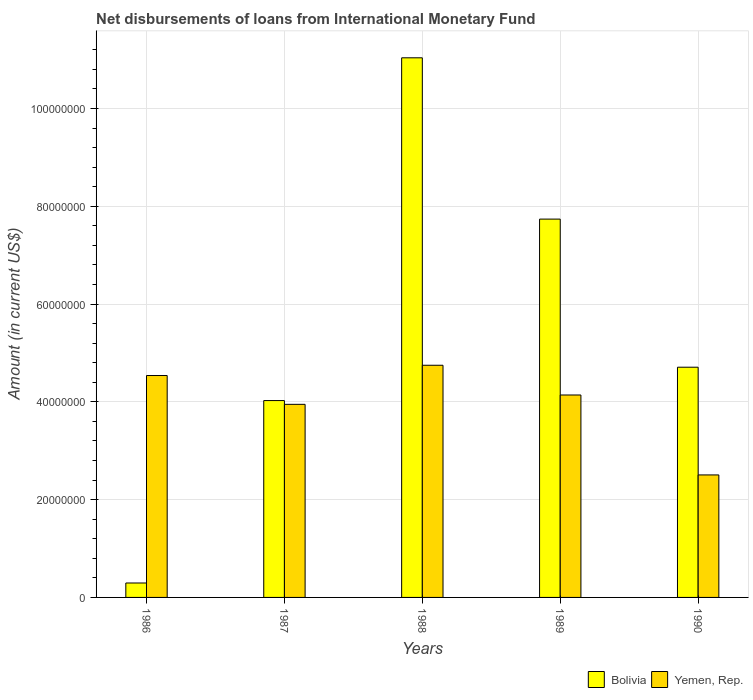How many different coloured bars are there?
Keep it short and to the point. 2. How many groups of bars are there?
Your answer should be very brief. 5. How many bars are there on the 2nd tick from the right?
Make the answer very short. 2. In how many cases, is the number of bars for a given year not equal to the number of legend labels?
Make the answer very short. 0. What is the amount of loans disbursed in Yemen, Rep. in 1988?
Offer a very short reply. 4.75e+07. Across all years, what is the maximum amount of loans disbursed in Yemen, Rep.?
Your answer should be very brief. 4.75e+07. Across all years, what is the minimum amount of loans disbursed in Bolivia?
Offer a very short reply. 2.95e+06. What is the total amount of loans disbursed in Bolivia in the graph?
Ensure brevity in your answer.  2.78e+08. What is the difference between the amount of loans disbursed in Bolivia in 1987 and that in 1988?
Give a very brief answer. -7.01e+07. What is the difference between the amount of loans disbursed in Yemen, Rep. in 1988 and the amount of loans disbursed in Bolivia in 1987?
Your answer should be very brief. 7.22e+06. What is the average amount of loans disbursed in Bolivia per year?
Ensure brevity in your answer.  5.56e+07. In the year 1990, what is the difference between the amount of loans disbursed in Yemen, Rep. and amount of loans disbursed in Bolivia?
Make the answer very short. -2.20e+07. In how many years, is the amount of loans disbursed in Bolivia greater than 16000000 US$?
Make the answer very short. 4. What is the ratio of the amount of loans disbursed in Yemen, Rep. in 1988 to that in 1990?
Keep it short and to the point. 1.9. Is the amount of loans disbursed in Yemen, Rep. in 1987 less than that in 1990?
Ensure brevity in your answer.  No. What is the difference between the highest and the second highest amount of loans disbursed in Bolivia?
Make the answer very short. 3.30e+07. What is the difference between the highest and the lowest amount of loans disbursed in Bolivia?
Your answer should be compact. 1.07e+08. Is the sum of the amount of loans disbursed in Yemen, Rep. in 1989 and 1990 greater than the maximum amount of loans disbursed in Bolivia across all years?
Offer a terse response. No. What does the 2nd bar from the left in 1990 represents?
Provide a short and direct response. Yemen, Rep. What does the 1st bar from the right in 1989 represents?
Keep it short and to the point. Yemen, Rep. How many bars are there?
Your answer should be very brief. 10. Are all the bars in the graph horizontal?
Offer a very short reply. No. How many years are there in the graph?
Offer a very short reply. 5. What is the difference between two consecutive major ticks on the Y-axis?
Your answer should be very brief. 2.00e+07. Are the values on the major ticks of Y-axis written in scientific E-notation?
Provide a short and direct response. No. How many legend labels are there?
Your answer should be compact. 2. What is the title of the graph?
Your answer should be very brief. Net disbursements of loans from International Monetary Fund. Does "Kyrgyz Republic" appear as one of the legend labels in the graph?
Ensure brevity in your answer.  No. What is the label or title of the X-axis?
Offer a very short reply. Years. What is the label or title of the Y-axis?
Make the answer very short. Amount (in current US$). What is the Amount (in current US$) of Bolivia in 1986?
Provide a succinct answer. 2.95e+06. What is the Amount (in current US$) of Yemen, Rep. in 1986?
Make the answer very short. 4.54e+07. What is the Amount (in current US$) of Bolivia in 1987?
Give a very brief answer. 4.03e+07. What is the Amount (in current US$) of Yemen, Rep. in 1987?
Keep it short and to the point. 3.95e+07. What is the Amount (in current US$) of Bolivia in 1988?
Give a very brief answer. 1.10e+08. What is the Amount (in current US$) of Yemen, Rep. in 1988?
Offer a terse response. 4.75e+07. What is the Amount (in current US$) of Bolivia in 1989?
Keep it short and to the point. 7.74e+07. What is the Amount (in current US$) of Yemen, Rep. in 1989?
Offer a terse response. 4.14e+07. What is the Amount (in current US$) of Bolivia in 1990?
Your response must be concise. 4.71e+07. What is the Amount (in current US$) in Yemen, Rep. in 1990?
Ensure brevity in your answer.  2.51e+07. Across all years, what is the maximum Amount (in current US$) in Bolivia?
Your answer should be very brief. 1.10e+08. Across all years, what is the maximum Amount (in current US$) in Yemen, Rep.?
Your response must be concise. 4.75e+07. Across all years, what is the minimum Amount (in current US$) of Bolivia?
Your response must be concise. 2.95e+06. Across all years, what is the minimum Amount (in current US$) of Yemen, Rep.?
Offer a very short reply. 2.51e+07. What is the total Amount (in current US$) of Bolivia in the graph?
Your response must be concise. 2.78e+08. What is the total Amount (in current US$) of Yemen, Rep. in the graph?
Provide a succinct answer. 1.99e+08. What is the difference between the Amount (in current US$) of Bolivia in 1986 and that in 1987?
Your answer should be very brief. -3.73e+07. What is the difference between the Amount (in current US$) in Yemen, Rep. in 1986 and that in 1987?
Your response must be concise. 5.89e+06. What is the difference between the Amount (in current US$) of Bolivia in 1986 and that in 1988?
Make the answer very short. -1.07e+08. What is the difference between the Amount (in current US$) of Yemen, Rep. in 1986 and that in 1988?
Your response must be concise. -2.10e+06. What is the difference between the Amount (in current US$) of Bolivia in 1986 and that in 1989?
Offer a very short reply. -7.44e+07. What is the difference between the Amount (in current US$) in Yemen, Rep. in 1986 and that in 1989?
Your answer should be very brief. 3.98e+06. What is the difference between the Amount (in current US$) in Bolivia in 1986 and that in 1990?
Provide a short and direct response. -4.41e+07. What is the difference between the Amount (in current US$) in Yemen, Rep. in 1986 and that in 1990?
Provide a short and direct response. 2.03e+07. What is the difference between the Amount (in current US$) of Bolivia in 1987 and that in 1988?
Offer a terse response. -7.01e+07. What is the difference between the Amount (in current US$) of Yemen, Rep. in 1987 and that in 1988?
Keep it short and to the point. -7.99e+06. What is the difference between the Amount (in current US$) of Bolivia in 1987 and that in 1989?
Provide a succinct answer. -3.71e+07. What is the difference between the Amount (in current US$) in Yemen, Rep. in 1987 and that in 1989?
Provide a short and direct response. -1.91e+06. What is the difference between the Amount (in current US$) of Bolivia in 1987 and that in 1990?
Your response must be concise. -6.82e+06. What is the difference between the Amount (in current US$) in Yemen, Rep. in 1987 and that in 1990?
Provide a short and direct response. 1.44e+07. What is the difference between the Amount (in current US$) in Bolivia in 1988 and that in 1989?
Your answer should be very brief. 3.30e+07. What is the difference between the Amount (in current US$) of Yemen, Rep. in 1988 and that in 1989?
Offer a terse response. 6.08e+06. What is the difference between the Amount (in current US$) of Bolivia in 1988 and that in 1990?
Make the answer very short. 6.33e+07. What is the difference between the Amount (in current US$) of Yemen, Rep. in 1988 and that in 1990?
Provide a succinct answer. 2.24e+07. What is the difference between the Amount (in current US$) in Bolivia in 1989 and that in 1990?
Provide a succinct answer. 3.03e+07. What is the difference between the Amount (in current US$) of Yemen, Rep. in 1989 and that in 1990?
Your answer should be very brief. 1.64e+07. What is the difference between the Amount (in current US$) in Bolivia in 1986 and the Amount (in current US$) in Yemen, Rep. in 1987?
Give a very brief answer. -3.65e+07. What is the difference between the Amount (in current US$) in Bolivia in 1986 and the Amount (in current US$) in Yemen, Rep. in 1988?
Offer a very short reply. -4.45e+07. What is the difference between the Amount (in current US$) of Bolivia in 1986 and the Amount (in current US$) of Yemen, Rep. in 1989?
Your answer should be very brief. -3.85e+07. What is the difference between the Amount (in current US$) in Bolivia in 1986 and the Amount (in current US$) in Yemen, Rep. in 1990?
Provide a short and direct response. -2.21e+07. What is the difference between the Amount (in current US$) in Bolivia in 1987 and the Amount (in current US$) in Yemen, Rep. in 1988?
Offer a terse response. -7.22e+06. What is the difference between the Amount (in current US$) of Bolivia in 1987 and the Amount (in current US$) of Yemen, Rep. in 1989?
Ensure brevity in your answer.  -1.14e+06. What is the difference between the Amount (in current US$) in Bolivia in 1987 and the Amount (in current US$) in Yemen, Rep. in 1990?
Provide a short and direct response. 1.52e+07. What is the difference between the Amount (in current US$) in Bolivia in 1988 and the Amount (in current US$) in Yemen, Rep. in 1989?
Keep it short and to the point. 6.90e+07. What is the difference between the Amount (in current US$) in Bolivia in 1988 and the Amount (in current US$) in Yemen, Rep. in 1990?
Offer a very short reply. 8.53e+07. What is the difference between the Amount (in current US$) of Bolivia in 1989 and the Amount (in current US$) of Yemen, Rep. in 1990?
Make the answer very short. 5.23e+07. What is the average Amount (in current US$) in Bolivia per year?
Offer a very short reply. 5.56e+07. What is the average Amount (in current US$) in Yemen, Rep. per year?
Keep it short and to the point. 3.98e+07. In the year 1986, what is the difference between the Amount (in current US$) in Bolivia and Amount (in current US$) in Yemen, Rep.?
Ensure brevity in your answer.  -4.24e+07. In the year 1987, what is the difference between the Amount (in current US$) in Bolivia and Amount (in current US$) in Yemen, Rep.?
Your answer should be very brief. 7.70e+05. In the year 1988, what is the difference between the Amount (in current US$) in Bolivia and Amount (in current US$) in Yemen, Rep.?
Provide a short and direct response. 6.29e+07. In the year 1989, what is the difference between the Amount (in current US$) of Bolivia and Amount (in current US$) of Yemen, Rep.?
Offer a terse response. 3.60e+07. In the year 1990, what is the difference between the Amount (in current US$) in Bolivia and Amount (in current US$) in Yemen, Rep.?
Give a very brief answer. 2.20e+07. What is the ratio of the Amount (in current US$) of Bolivia in 1986 to that in 1987?
Provide a succinct answer. 0.07. What is the ratio of the Amount (in current US$) in Yemen, Rep. in 1986 to that in 1987?
Provide a succinct answer. 1.15. What is the ratio of the Amount (in current US$) in Bolivia in 1986 to that in 1988?
Keep it short and to the point. 0.03. What is the ratio of the Amount (in current US$) of Yemen, Rep. in 1986 to that in 1988?
Offer a very short reply. 0.96. What is the ratio of the Amount (in current US$) in Bolivia in 1986 to that in 1989?
Make the answer very short. 0.04. What is the ratio of the Amount (in current US$) of Yemen, Rep. in 1986 to that in 1989?
Offer a terse response. 1.1. What is the ratio of the Amount (in current US$) in Bolivia in 1986 to that in 1990?
Your answer should be very brief. 0.06. What is the ratio of the Amount (in current US$) of Yemen, Rep. in 1986 to that in 1990?
Provide a short and direct response. 1.81. What is the ratio of the Amount (in current US$) in Bolivia in 1987 to that in 1988?
Make the answer very short. 0.36. What is the ratio of the Amount (in current US$) in Yemen, Rep. in 1987 to that in 1988?
Offer a very short reply. 0.83. What is the ratio of the Amount (in current US$) in Bolivia in 1987 to that in 1989?
Your answer should be very brief. 0.52. What is the ratio of the Amount (in current US$) in Yemen, Rep. in 1987 to that in 1989?
Your answer should be very brief. 0.95. What is the ratio of the Amount (in current US$) in Bolivia in 1987 to that in 1990?
Your response must be concise. 0.86. What is the ratio of the Amount (in current US$) of Yemen, Rep. in 1987 to that in 1990?
Offer a very short reply. 1.58. What is the ratio of the Amount (in current US$) in Bolivia in 1988 to that in 1989?
Your answer should be compact. 1.43. What is the ratio of the Amount (in current US$) in Yemen, Rep. in 1988 to that in 1989?
Offer a terse response. 1.15. What is the ratio of the Amount (in current US$) of Bolivia in 1988 to that in 1990?
Provide a succinct answer. 2.34. What is the ratio of the Amount (in current US$) of Yemen, Rep. in 1988 to that in 1990?
Give a very brief answer. 1.9. What is the ratio of the Amount (in current US$) of Bolivia in 1989 to that in 1990?
Ensure brevity in your answer.  1.64. What is the ratio of the Amount (in current US$) of Yemen, Rep. in 1989 to that in 1990?
Your answer should be very brief. 1.65. What is the difference between the highest and the second highest Amount (in current US$) of Bolivia?
Offer a very short reply. 3.30e+07. What is the difference between the highest and the second highest Amount (in current US$) in Yemen, Rep.?
Keep it short and to the point. 2.10e+06. What is the difference between the highest and the lowest Amount (in current US$) of Bolivia?
Ensure brevity in your answer.  1.07e+08. What is the difference between the highest and the lowest Amount (in current US$) in Yemen, Rep.?
Give a very brief answer. 2.24e+07. 